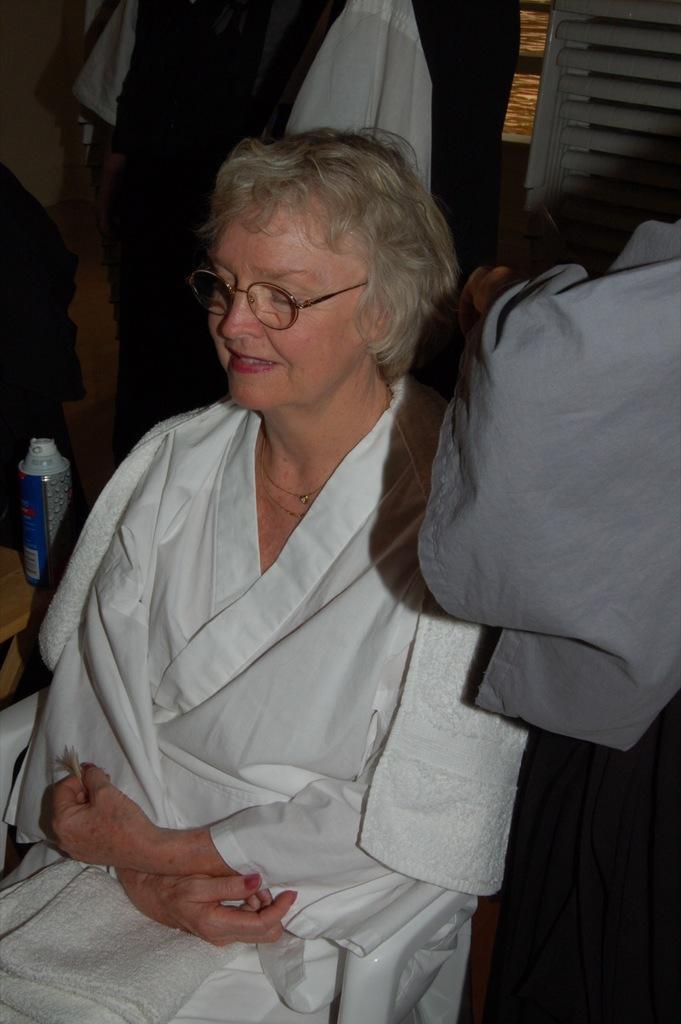Please provide a concise description of this image. In this image we can see a woman sitting on chair and to the side, we can see a person and we can see a bottle on the table. There are some clothes and objects in the background. 